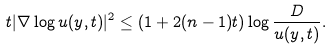<formula> <loc_0><loc_0><loc_500><loc_500>t | \nabla \log u ( y , t ) | ^ { 2 } \leq ( 1 + 2 ( n - 1 ) t ) \log \frac { D } { u ( y , t ) } .</formula> 